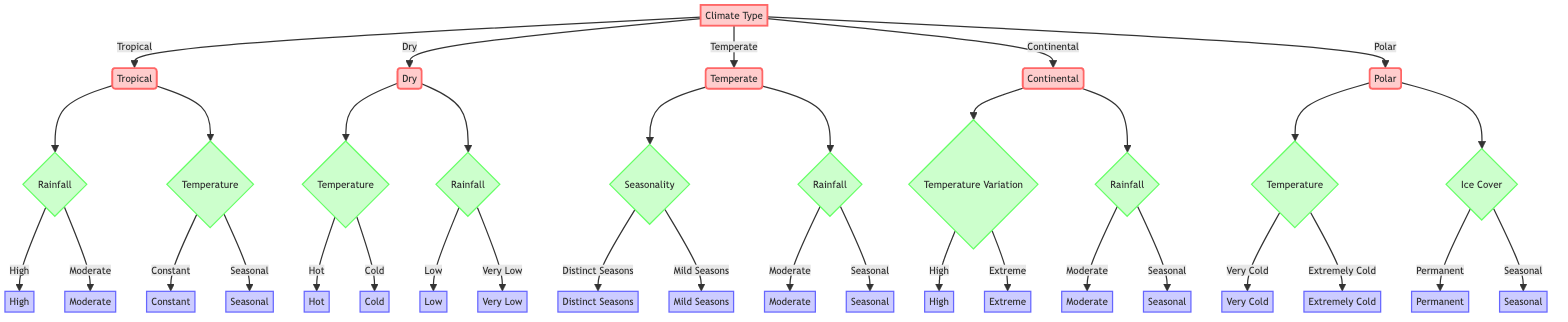What are the main climate types shown in the diagram? The main climate types are presented at the top node of the diagram, directly coming from the main decision tree element. They are Tropical, Dry, Temperate, Continental, and Polar.
Answer: Tropical, Dry, Temperate, Continental, Polar How many criteria are used to classify the Tropical biome? The Tropical biome has two main criteria that lead to further classifications: Rainfall and Temperature. Each of these criteria is a decision point leading to specific values.
Answer: 2 What is one of the temperature categories in the Dry biome? The Dry biome has two temperature categories: Hot and Cold. This information is referenced from the decision tree where Temperature criteria branches into these two categories.
Answer: Hot What are the values associated with the Rainfall criteria in the Temperate biome? The Rainfall criteria for the Temperate biome branches into two values: Moderate and Seasonal. This is derived from the section of the diagram pertaining to the Temperate biome decision process.
Answer: Moderate, Seasonal Which biome is associated with "Very Cold" temperatures? The category "Very Cold" is found under the Temperature criteria of the Polar biome. The diagram shows that this is a defining characteristic of the Polar climatic type.
Answer: Polar If a region has distinct seasons and moderate rainfall, which biome does it fall into? Regions with distinct seasons and moderate rainfall can be traced to the Temperate biome. The decision tree shows that both conditions lead to the classification of Temperate.
Answer: Temperate What is the relationship between "Ice Cover" and the Polar biome? The relationship is that the Polar biome is analyzed under two Ice Cover scenarios: Permanent and Seasonal. This branching reveals important characteristics that define the Polar climatic classification.
Answer: Ice Cover How many different categories of Rainfall are present in the Dry biome? In the Dry biome, there are two categories of Rainfall: Low and Very Low as determined by the specific branches stemming from the Rainfall criteria.
Answer: 2 Which climatic type has a criterion of "Temperature Variation"? The Continental biome includes Temperature Variation as a criterion. The diagram explicitly shows that this classification criterion is unique to the Continental type.
Answer: Continental 